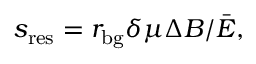Convert formula to latex. <formula><loc_0><loc_0><loc_500><loc_500>s _ { r e s } = r _ { b g } \delta \mu \Delta B / \bar { E } ,</formula> 